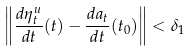Convert formula to latex. <formula><loc_0><loc_0><loc_500><loc_500>\left \| \frac { d \eta _ { t } ^ { u } } { d t } ( t ) - \frac { d a _ { t } } { d t } ( t _ { 0 } ) \right \| < \delta _ { 1 }</formula> 